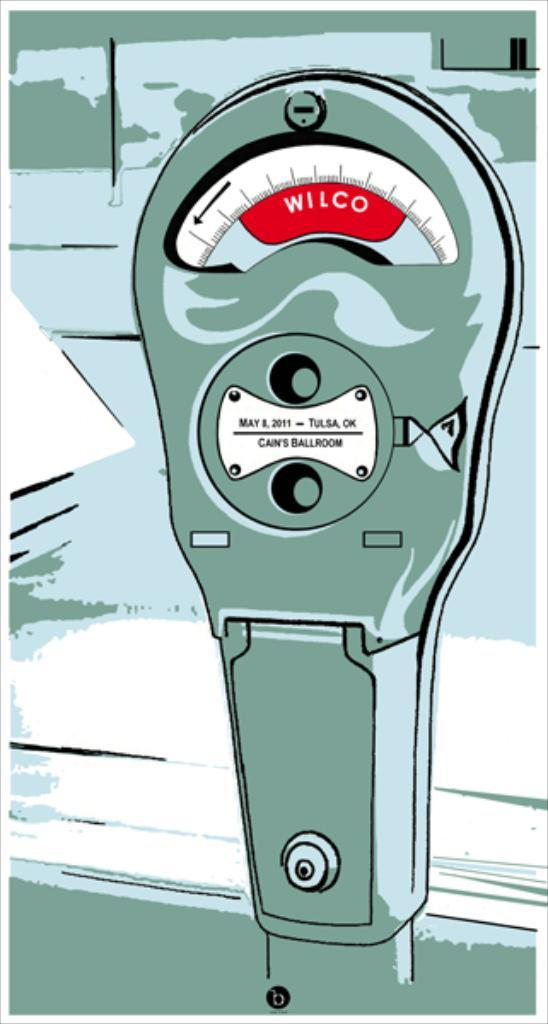<image>
Present a compact description of the photo's key features. A graphic for an old Wilco parking meter has a small plaque for Cann's Ballroom in Tulsa, OK. 